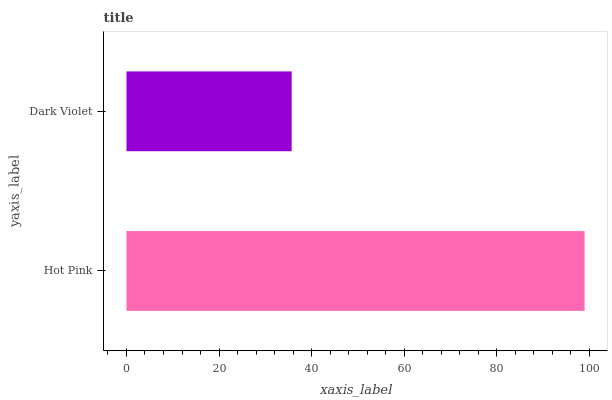Is Dark Violet the minimum?
Answer yes or no. Yes. Is Hot Pink the maximum?
Answer yes or no. Yes. Is Dark Violet the maximum?
Answer yes or no. No. Is Hot Pink greater than Dark Violet?
Answer yes or no. Yes. Is Dark Violet less than Hot Pink?
Answer yes or no. Yes. Is Dark Violet greater than Hot Pink?
Answer yes or no. No. Is Hot Pink less than Dark Violet?
Answer yes or no. No. Is Hot Pink the high median?
Answer yes or no. Yes. Is Dark Violet the low median?
Answer yes or no. Yes. Is Dark Violet the high median?
Answer yes or no. No. Is Hot Pink the low median?
Answer yes or no. No. 